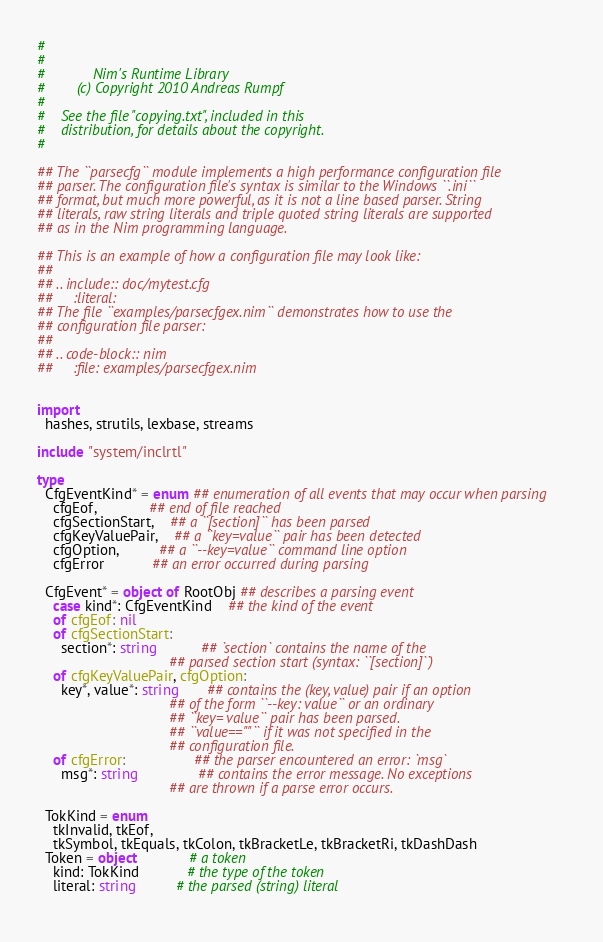<code> <loc_0><loc_0><loc_500><loc_500><_Nim_>#
#
#            Nim's Runtime Library
#        (c) Copyright 2010 Andreas Rumpf
#
#    See the file "copying.txt", included in this
#    distribution, for details about the copyright.
#

## The ``parsecfg`` module implements a high performance configuration file 
## parser. The configuration file's syntax is similar to the Windows ``.ini`` 
## format, but much more powerful, as it is not a line based parser. String 
## literals, raw string literals and triple quoted string literals are supported 
## as in the Nim programming language.

## This is an example of how a configuration file may look like:
##
## .. include:: doc/mytest.cfg
##     :literal:
## The file ``examples/parsecfgex.nim`` demonstrates how to use the 
## configuration file parser:
##
## .. code-block:: nim
##     :file: examples/parsecfgex.nim


import
  hashes, strutils, lexbase, streams

include "system/inclrtl"

type
  CfgEventKind* = enum ## enumeration of all events that may occur when parsing
    cfgEof,             ## end of file reached
    cfgSectionStart,    ## a ``[section]`` has been parsed
    cfgKeyValuePair,    ## a ``key=value`` pair has been detected
    cfgOption,          ## a ``--key=value`` command line option
    cfgError            ## an error occurred during parsing
    
  CfgEvent* = object of RootObj ## describes a parsing event
    case kind*: CfgEventKind    ## the kind of the event
    of cfgEof: nil
    of cfgSectionStart: 
      section*: string           ## `section` contains the name of the 
                                 ## parsed section start (syntax: ``[section]``)
    of cfgKeyValuePair, cfgOption: 
      key*, value*: string       ## contains the (key, value) pair if an option
                                 ## of the form ``--key: value`` or an ordinary
                                 ## ``key= value`` pair has been parsed.
                                 ## ``value==""`` if it was not specified in the
                                 ## configuration file.
    of cfgError:                 ## the parser encountered an error: `msg`
      msg*: string               ## contains the error message. No exceptions
                                 ## are thrown if a parse error occurs.
  
  TokKind = enum 
    tkInvalid, tkEof,        
    tkSymbol, tkEquals, tkColon, tkBracketLe, tkBracketRi, tkDashDash
  Token = object             # a token
    kind: TokKind            # the type of the token
    literal: string          # the parsed (string) literal
  </code> 